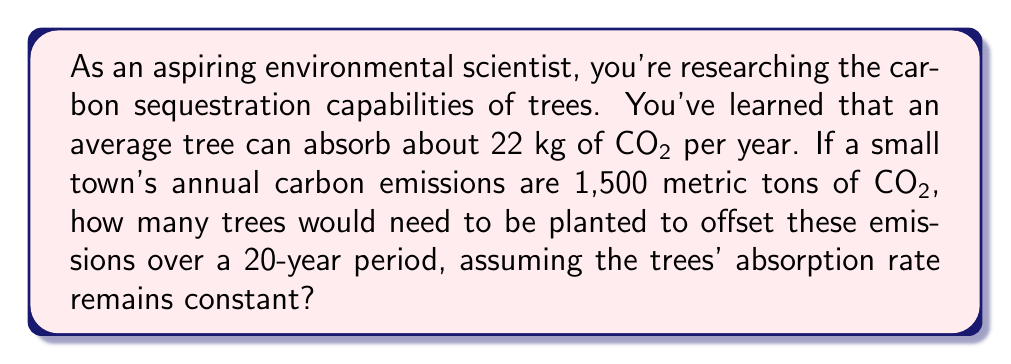Solve this math problem. To solve this problem, we need to follow these steps:

1. Convert the town's annual emissions from metric tons to kilograms:
   $$ 1,500 \text{ metric tons} = 1,500,000 \text{ kg} $$

2. Calculate the total emissions over 20 years:
   $$ 1,500,000 \text{ kg} \times 20 \text{ years} = 30,000,000 \text{ kg} $$

3. Calculate how much CO2 one tree can absorb over 20 years:
   $$ 22 \text{ kg/year} \times 20 \text{ years} = 440 \text{ kg} $$

4. Calculate the number of trees needed by dividing the total emissions by the absorption capacity of one tree:
   $$ \text{Number of trees} = \frac{\text{Total emissions}}{\text{Absorption per tree}} $$
   $$ \text{Number of trees} = \frac{30,000,000 \text{ kg}}{440 \text{ kg/tree}} $$
   $$ \text{Number of trees} = 68,181.82 $$

5. Since we can't plant a fraction of a tree, we round up to the nearest whole number:
   $$ \text{Number of trees} = 68,182 $$

Therefore, 68,182 trees would need to be planted to offset the town's carbon emissions over a 20-year period.
Answer: 68,182 trees 